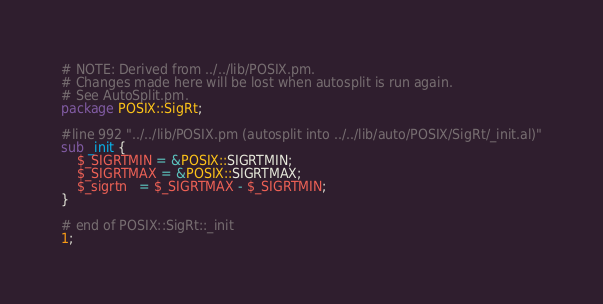Convert code to text. <code><loc_0><loc_0><loc_500><loc_500><_Perl_># NOTE: Derived from ../../lib/POSIX.pm.
# Changes made here will be lost when autosplit is run again.
# See AutoSplit.pm.
package POSIX::SigRt;

#line 992 "../../lib/POSIX.pm (autosplit into ../../lib/auto/POSIX/SigRt/_init.al)"
sub _init {
    $_SIGRTMIN = &POSIX::SIGRTMIN;
    $_SIGRTMAX = &POSIX::SIGRTMAX;
    $_sigrtn   = $_SIGRTMAX - $_SIGRTMIN;
}

# end of POSIX::SigRt::_init
1;
</code> 